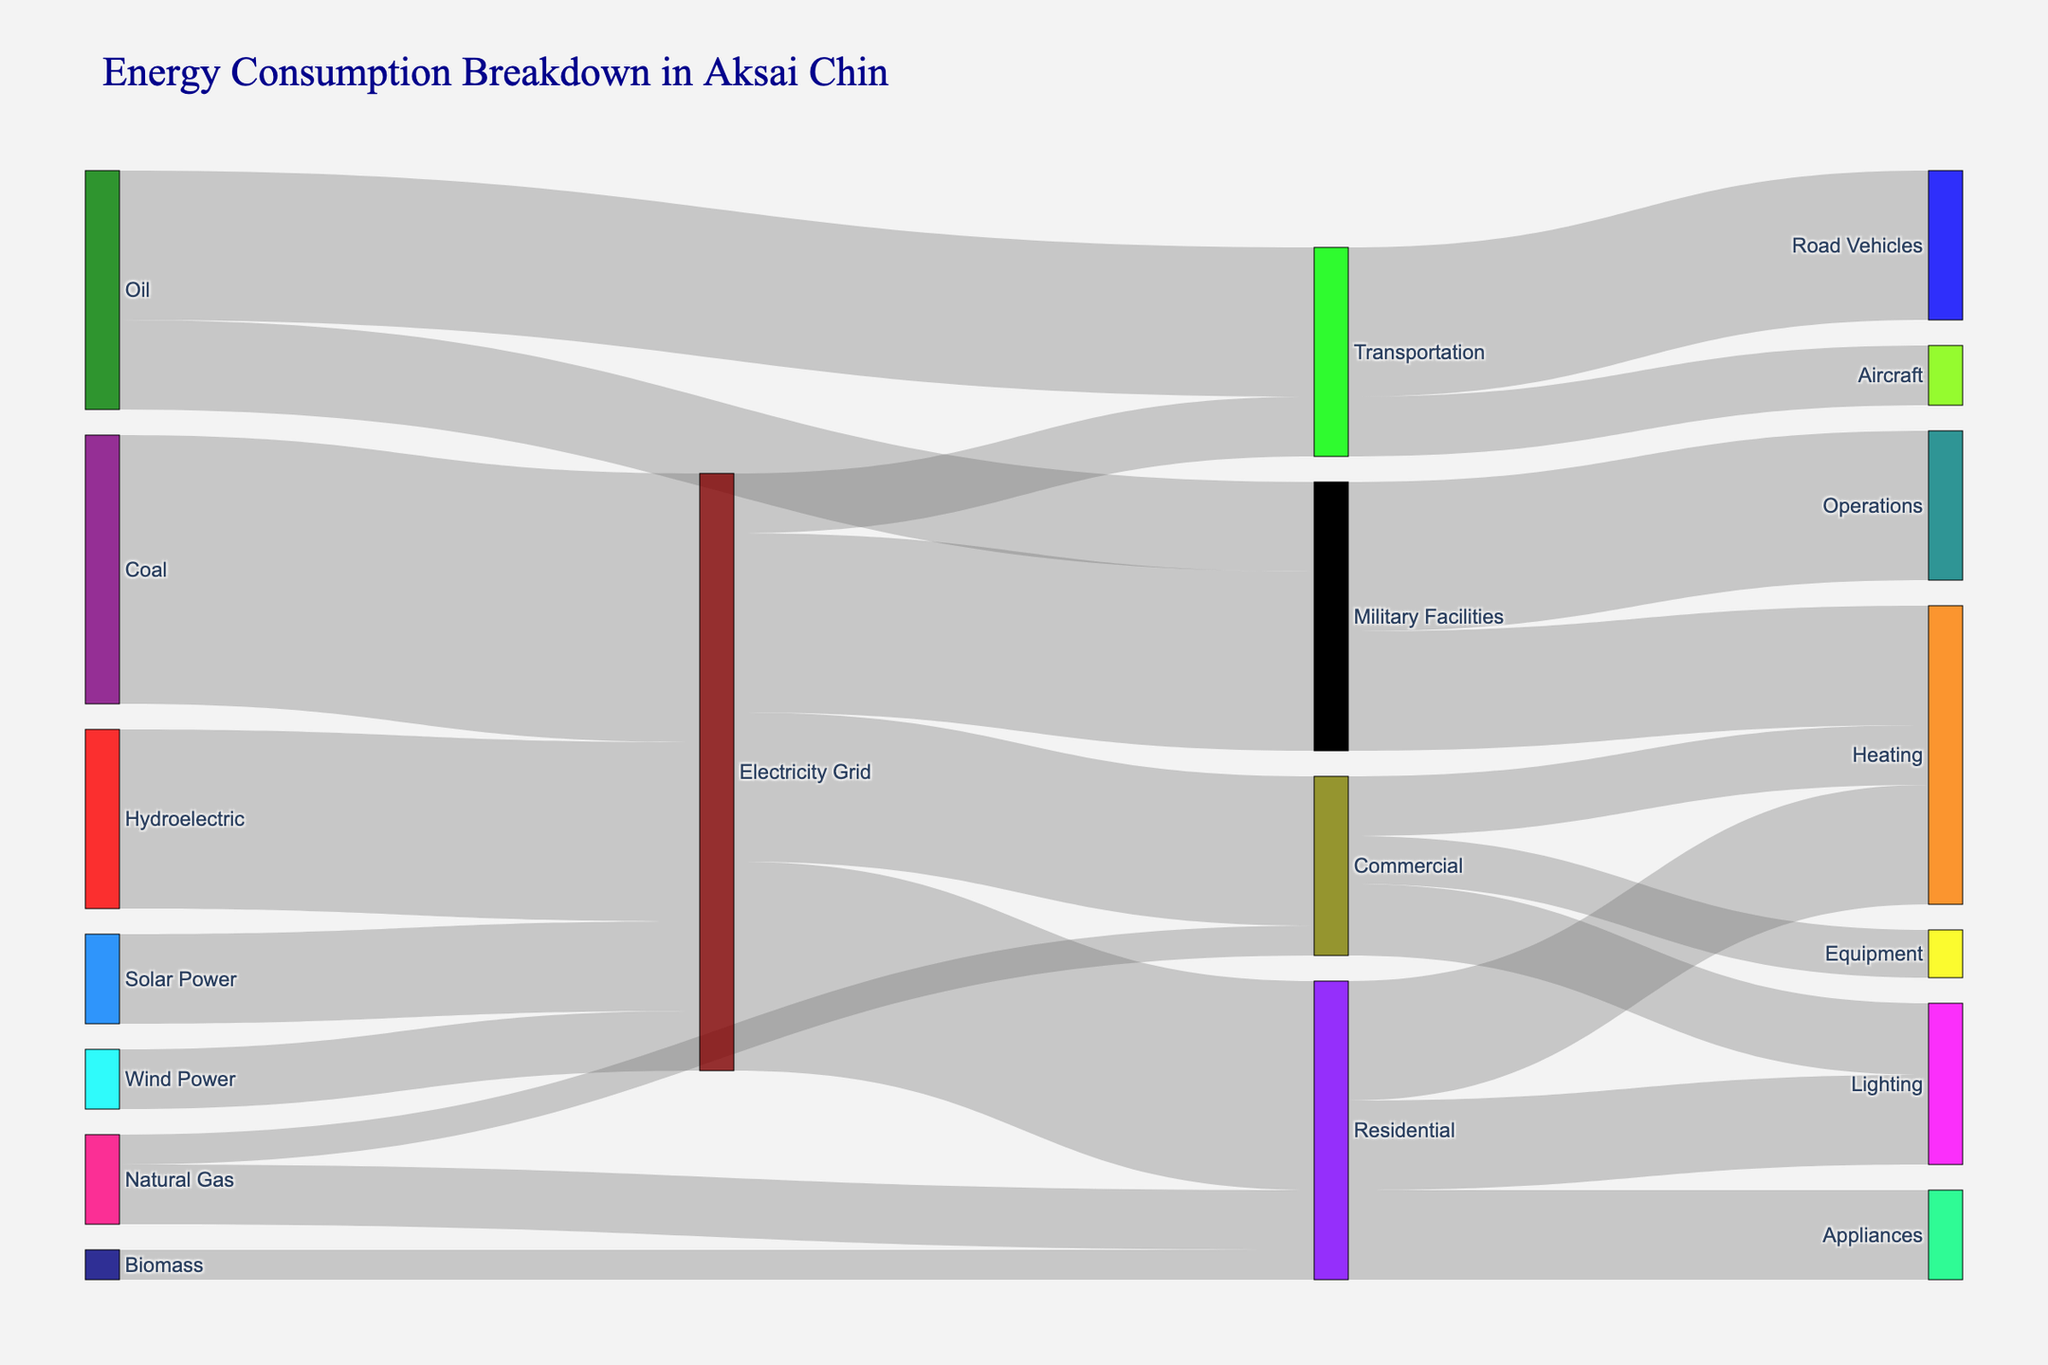What is the primary source of energy in the Electricity Grid? The Sankey Diagram shows multiple energy sources flowing toward the Electricity Grid. By comparing their values, it is evident that Coal has the largest contribution with a value of 45.
Answer: Coal How much energy is used for Residential Heating compared to Commercial Heating? The Sankey Diagram indicates energy flow from the Residential and Commercial sectors to various usages. Residential Heating receives 20 units, while Commercial Heating receives 10 units.
Answer: 20 vs. 10 What is the total amount of energy consumed by Military Facilities? By tracing all the energy flows leading to Military Facilities (Electricity Grid and Oil), we find two values: 30 from the Electricity Grid and 15 from Oil. Summing these, the total is 30 + 15 = 45 units.
Answer: 45 Which end-use sector receives the least amount of energy from the Electricity Grid? The end-use sectors from the Electricity Grid are Residential, Commercial, Military Facilities, and Transportation. By comparing the values, we see Transportation receives the least with 10 units.
Answer: Transportation What are the three main types of energy consumption in Residential areas and their values? The Sankey Diagram shows energy flow in the Residential sector to Heating, Lighting, and Appliances, with respective values of 20, 15, and 15.
Answer: Heating (20), Lighting (15), Appliances (15) Out of Natural Gas and Biomass, which energy source provides more energy to Residential areas and by how much? Natural Gas provides 10 units of energy while Biomass provides 5 units to Residential. Therefore, Natural Gas provides 10 - 5 = 5 units more than Biomass.
Answer: Natural Gas by 5 units Compare the amount of energy used for Road Vehicles versus Aircraft in the Transportation sector. The Sankey Diagram depicts energy usage in the Transportation sector, indicating Road Vehicles at 25 units and Aircraft at 10 units.
Answer: Road Vehicles use 15 units more than Aircraft How does the energy consumption of Appliances in Residential areas compare with Operations in Military Facilities? In the Sankey Diagram, Appliances in Residential areas have a value of 15, whereas Operations in Military Facilities have a value of 25. Comparing these, Operations consume more energy.
Answer: Operations consume 10 more units What's the total amount of energy directed towards the Commercial sector? Summing the energy flowing into the Commercial sector from both the Electricity Grid (25) and Natural Gas (5), the total is 25 + 5 = 30 units.
Answer: 30 Which energy source contributes the most to the Transportation sector, and what is its value? From the Sankey Diagram, it is clear that Oil contributes the most to the Transportation sector with a value of 25 units.
Answer: Oil (25 units) 